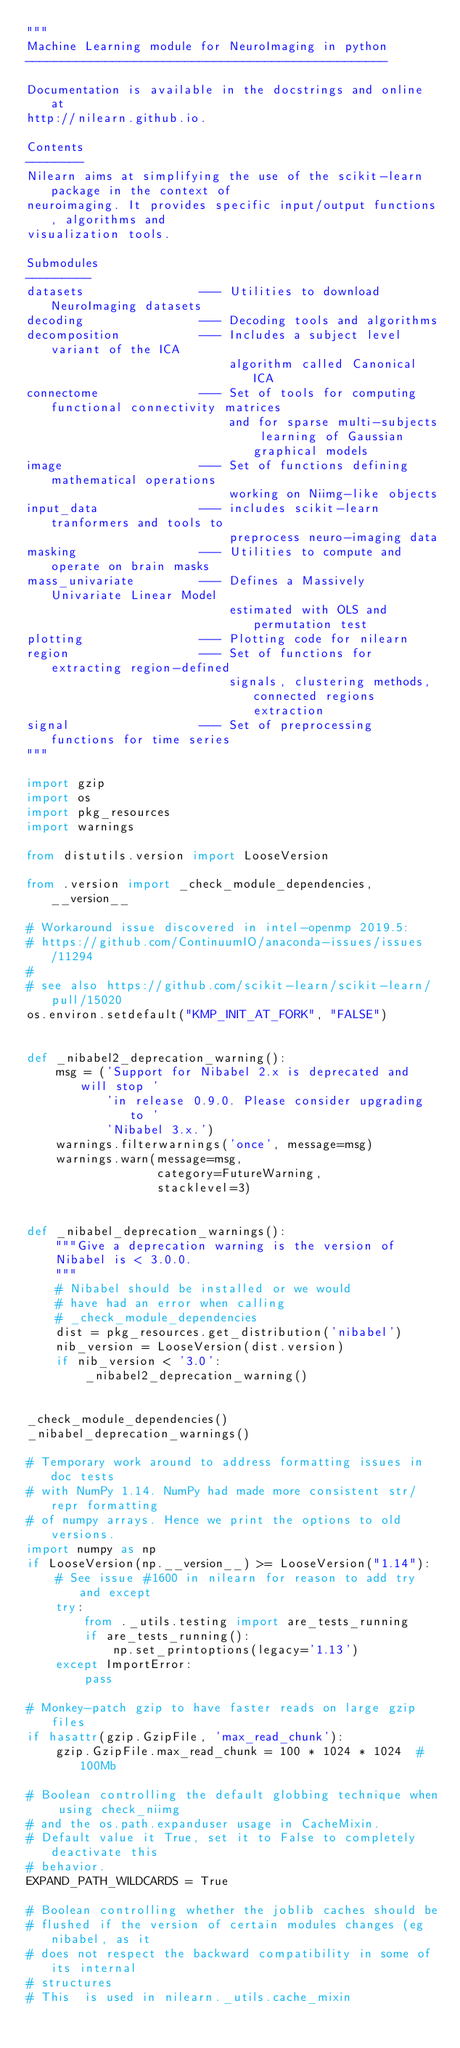<code> <loc_0><loc_0><loc_500><loc_500><_Python_>"""
Machine Learning module for NeuroImaging in python
--------------------------------------------------

Documentation is available in the docstrings and online at
http://nilearn.github.io.

Contents
--------
Nilearn aims at simplifying the use of the scikit-learn package in the context of
neuroimaging. It provides specific input/output functions, algorithms and
visualization tools.

Submodules
---------
datasets                --- Utilities to download NeuroImaging datasets
decoding                --- Decoding tools and algorithms
decomposition           --- Includes a subject level variant of the ICA
                            algorithm called Canonical ICA
connectome              --- Set of tools for computing functional connectivity matrices
                            and for sparse multi-subjects learning of Gaussian graphical models
image                   --- Set of functions defining mathematical operations
                            working on Niimg-like objects
input_data              --- includes scikit-learn tranformers and tools to
                            preprocess neuro-imaging data
masking                 --- Utilities to compute and operate on brain masks
mass_univariate         --- Defines a Massively Univariate Linear Model
                            estimated with OLS and permutation test
plotting                --- Plotting code for nilearn
region                  --- Set of functions for extracting region-defined
                            signals, clustering methods, connected regions extraction
signal                  --- Set of preprocessing functions for time series
"""

import gzip
import os
import pkg_resources
import warnings

from distutils.version import LooseVersion

from .version import _check_module_dependencies, __version__

# Workaround issue discovered in intel-openmp 2019.5:
# https://github.com/ContinuumIO/anaconda-issues/issues/11294
#
# see also https://github.com/scikit-learn/scikit-learn/pull/15020
os.environ.setdefault("KMP_INIT_AT_FORK", "FALSE")


def _nibabel2_deprecation_warning():
    msg = ('Support for Nibabel 2.x is deprecated and will stop '
           'in release 0.9.0. Please consider upgrading to '
           'Nibabel 3.x.')
    warnings.filterwarnings('once', message=msg)
    warnings.warn(message=msg,
                  category=FutureWarning,
                  stacklevel=3)


def _nibabel_deprecation_warnings():
    """Give a deprecation warning is the version of
    Nibabel is < 3.0.0.
    """
    # Nibabel should be installed or we would
    # have had an error when calling
    # _check_module_dependencies
    dist = pkg_resources.get_distribution('nibabel')
    nib_version = LooseVersion(dist.version)
    if nib_version < '3.0':
        _nibabel2_deprecation_warning()


_check_module_dependencies()
_nibabel_deprecation_warnings()

# Temporary work around to address formatting issues in doc tests
# with NumPy 1.14. NumPy had made more consistent str/repr formatting
# of numpy arrays. Hence we print the options to old versions.
import numpy as np
if LooseVersion(np.__version__) >= LooseVersion("1.14"):
    # See issue #1600 in nilearn for reason to add try and except
    try:
        from ._utils.testing import are_tests_running
        if are_tests_running():
            np.set_printoptions(legacy='1.13')
    except ImportError:
        pass

# Monkey-patch gzip to have faster reads on large gzip files
if hasattr(gzip.GzipFile, 'max_read_chunk'):
    gzip.GzipFile.max_read_chunk = 100 * 1024 * 1024  # 100Mb

# Boolean controlling the default globbing technique when using check_niimg
# and the os.path.expanduser usage in CacheMixin.
# Default value it True, set it to False to completely deactivate this
# behavior.
EXPAND_PATH_WILDCARDS = True

# Boolean controlling whether the joblib caches should be
# flushed if the version of certain modules changes (eg nibabel, as it
# does not respect the backward compatibility in some of its internal
# structures
# This  is used in nilearn._utils.cache_mixin</code> 